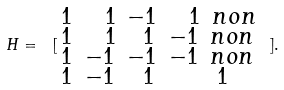Convert formula to latex. <formula><loc_0><loc_0><loc_500><loc_500>H = \ [ \begin{smallmatrix} 1 & \ \ 1 & - 1 & \ \ 1 \ n o n \\ 1 & \ \ 1 & \ \, 1 & - 1 \ n o n \\ 1 & - 1 & - 1 & - 1 \ n o n \\ 1 & - 1 & \ \, 1 & \ \ 1 \end{smallmatrix} \ ] .</formula> 